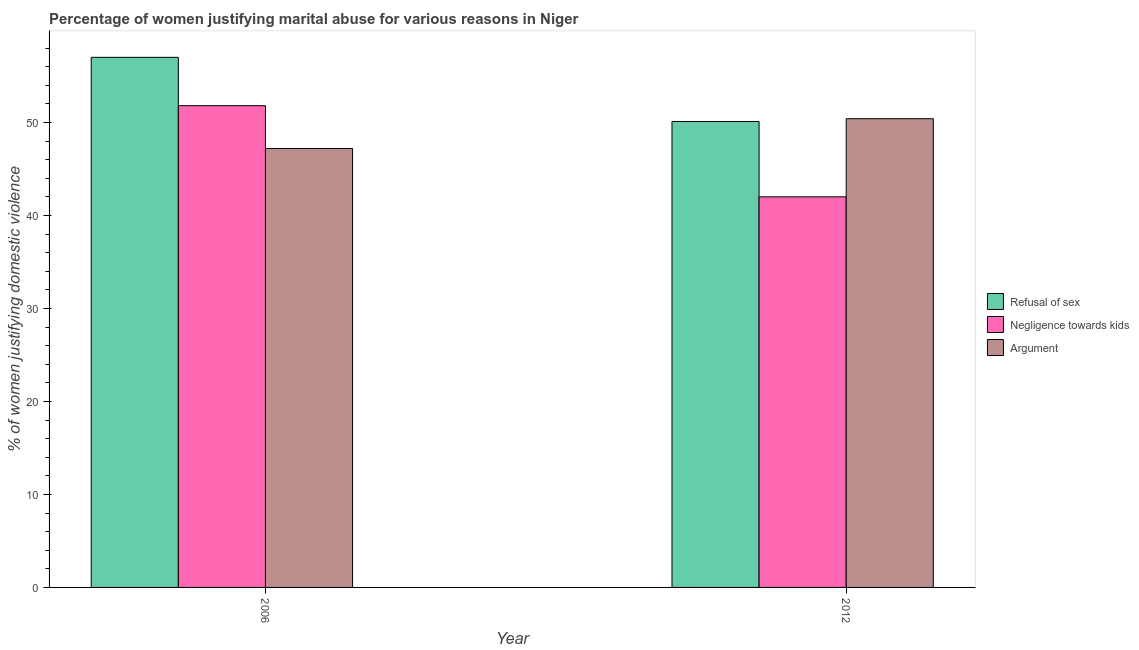How many different coloured bars are there?
Keep it short and to the point. 3. Are the number of bars per tick equal to the number of legend labels?
Your response must be concise. Yes. Are the number of bars on each tick of the X-axis equal?
Make the answer very short. Yes. How many bars are there on the 2nd tick from the right?
Your answer should be very brief. 3. What is the percentage of women justifying domestic violence due to arguments in 2012?
Provide a succinct answer. 50.4. Across all years, what is the maximum percentage of women justifying domestic violence due to arguments?
Ensure brevity in your answer.  50.4. In which year was the percentage of women justifying domestic violence due to arguments maximum?
Your answer should be very brief. 2012. What is the total percentage of women justifying domestic violence due to arguments in the graph?
Ensure brevity in your answer.  97.6. What is the difference between the percentage of women justifying domestic violence due to negligence towards kids in 2006 and that in 2012?
Your answer should be compact. 9.8. What is the difference between the percentage of women justifying domestic violence due to arguments in 2006 and the percentage of women justifying domestic violence due to negligence towards kids in 2012?
Your answer should be very brief. -3.2. What is the average percentage of women justifying domestic violence due to negligence towards kids per year?
Give a very brief answer. 46.9. In how many years, is the percentage of women justifying domestic violence due to negligence towards kids greater than 4 %?
Keep it short and to the point. 2. What is the ratio of the percentage of women justifying domestic violence due to negligence towards kids in 2006 to that in 2012?
Ensure brevity in your answer.  1.23. What does the 3rd bar from the left in 2012 represents?
Your response must be concise. Argument. What does the 1st bar from the right in 2006 represents?
Provide a short and direct response. Argument. Is it the case that in every year, the sum of the percentage of women justifying domestic violence due to refusal of sex and percentage of women justifying domestic violence due to negligence towards kids is greater than the percentage of women justifying domestic violence due to arguments?
Ensure brevity in your answer.  Yes. How many bars are there?
Your answer should be compact. 6. Are the values on the major ticks of Y-axis written in scientific E-notation?
Offer a terse response. No. Where does the legend appear in the graph?
Provide a succinct answer. Center right. How many legend labels are there?
Give a very brief answer. 3. How are the legend labels stacked?
Offer a very short reply. Vertical. What is the title of the graph?
Provide a succinct answer. Percentage of women justifying marital abuse for various reasons in Niger. What is the label or title of the X-axis?
Give a very brief answer. Year. What is the label or title of the Y-axis?
Provide a short and direct response. % of women justifying domestic violence. What is the % of women justifying domestic violence of Refusal of sex in 2006?
Your answer should be very brief. 57. What is the % of women justifying domestic violence of Negligence towards kids in 2006?
Keep it short and to the point. 51.8. What is the % of women justifying domestic violence of Argument in 2006?
Give a very brief answer. 47.2. What is the % of women justifying domestic violence of Refusal of sex in 2012?
Give a very brief answer. 50.1. What is the % of women justifying domestic violence in Argument in 2012?
Offer a terse response. 50.4. Across all years, what is the maximum % of women justifying domestic violence of Refusal of sex?
Offer a very short reply. 57. Across all years, what is the maximum % of women justifying domestic violence in Negligence towards kids?
Your answer should be very brief. 51.8. Across all years, what is the maximum % of women justifying domestic violence of Argument?
Provide a short and direct response. 50.4. Across all years, what is the minimum % of women justifying domestic violence in Refusal of sex?
Your answer should be compact. 50.1. Across all years, what is the minimum % of women justifying domestic violence in Argument?
Give a very brief answer. 47.2. What is the total % of women justifying domestic violence of Refusal of sex in the graph?
Ensure brevity in your answer.  107.1. What is the total % of women justifying domestic violence in Negligence towards kids in the graph?
Provide a succinct answer. 93.8. What is the total % of women justifying domestic violence of Argument in the graph?
Provide a short and direct response. 97.6. What is the difference between the % of women justifying domestic violence of Refusal of sex in 2006 and that in 2012?
Provide a short and direct response. 6.9. What is the difference between the % of women justifying domestic violence in Argument in 2006 and that in 2012?
Provide a short and direct response. -3.2. What is the average % of women justifying domestic violence of Refusal of sex per year?
Provide a short and direct response. 53.55. What is the average % of women justifying domestic violence in Negligence towards kids per year?
Offer a terse response. 46.9. What is the average % of women justifying domestic violence in Argument per year?
Your answer should be compact. 48.8. In the year 2006, what is the difference between the % of women justifying domestic violence of Negligence towards kids and % of women justifying domestic violence of Argument?
Offer a terse response. 4.6. In the year 2012, what is the difference between the % of women justifying domestic violence of Refusal of sex and % of women justifying domestic violence of Argument?
Provide a short and direct response. -0.3. In the year 2012, what is the difference between the % of women justifying domestic violence of Negligence towards kids and % of women justifying domestic violence of Argument?
Provide a short and direct response. -8.4. What is the ratio of the % of women justifying domestic violence of Refusal of sex in 2006 to that in 2012?
Give a very brief answer. 1.14. What is the ratio of the % of women justifying domestic violence in Negligence towards kids in 2006 to that in 2012?
Keep it short and to the point. 1.23. What is the ratio of the % of women justifying domestic violence in Argument in 2006 to that in 2012?
Offer a very short reply. 0.94. What is the difference between the highest and the lowest % of women justifying domestic violence of Negligence towards kids?
Provide a succinct answer. 9.8. What is the difference between the highest and the lowest % of women justifying domestic violence in Argument?
Offer a very short reply. 3.2. 